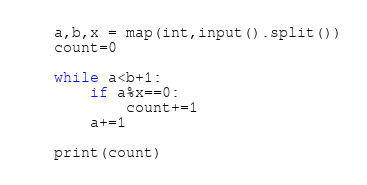Convert code to text. <code><loc_0><loc_0><loc_500><loc_500><_Python_>a,b,x = map(int,input().split())
count=0

while a<b+1:
    if a%x==0:
        count+=1
    a+=1

print(count)
</code> 